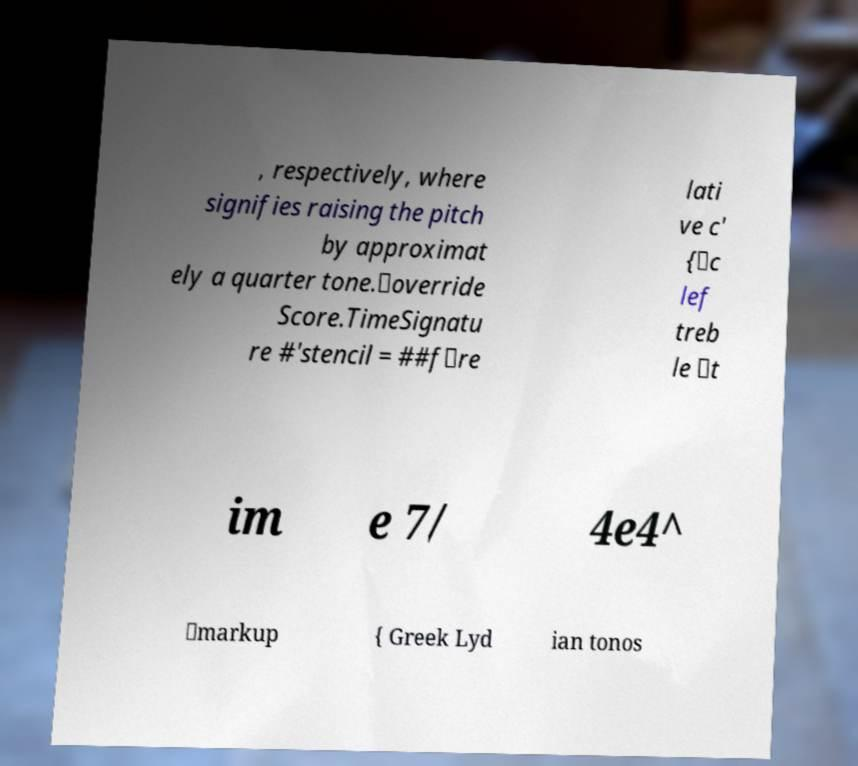Can you read and provide the text displayed in the image?This photo seems to have some interesting text. Can you extract and type it out for me? , respectively, where signifies raising the pitch by approximat ely a quarter tone.\override Score.TimeSignatu re #'stencil = ##f\re lati ve c' {\c lef treb le \t im e 7/ 4e4^ \markup { Greek Lyd ian tonos 